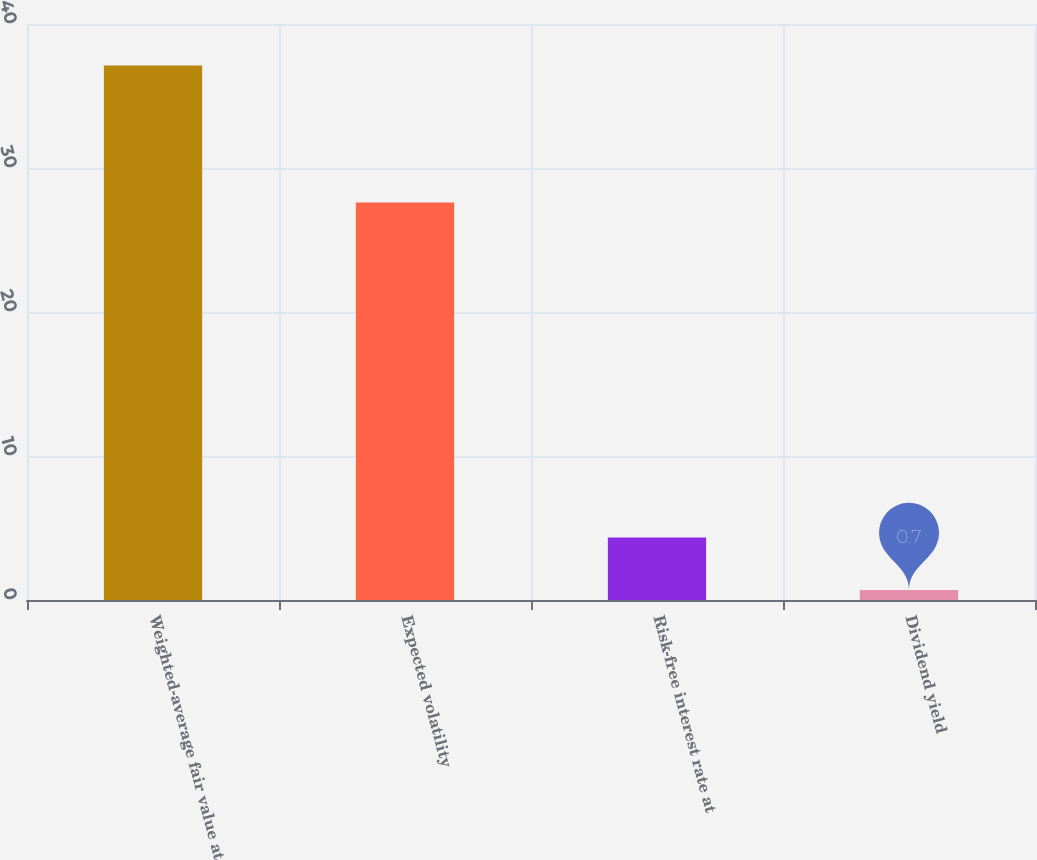Convert chart to OTSL. <chart><loc_0><loc_0><loc_500><loc_500><bar_chart><fcel>Weighted-average fair value at<fcel>Expected volatility<fcel>Risk-free interest rate at<fcel>Dividend yield<nl><fcel>37.12<fcel>27.6<fcel>4.34<fcel>0.7<nl></chart> 